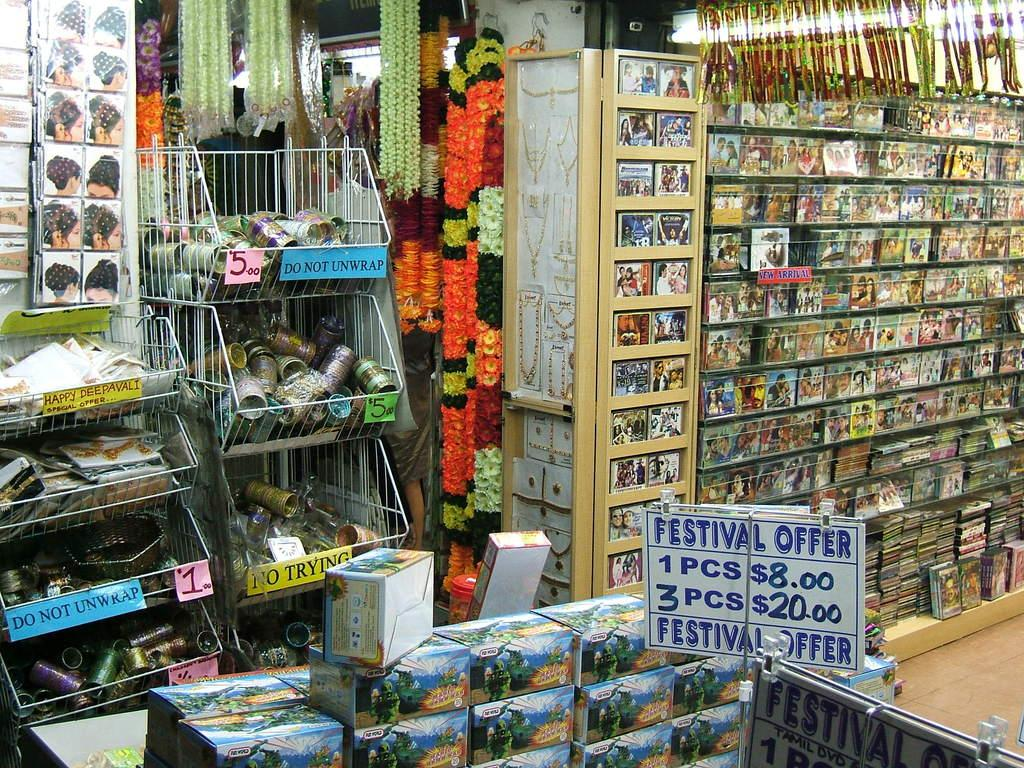Provide a one-sentence caption for the provided image. A store with a display advertising a festival offer. 